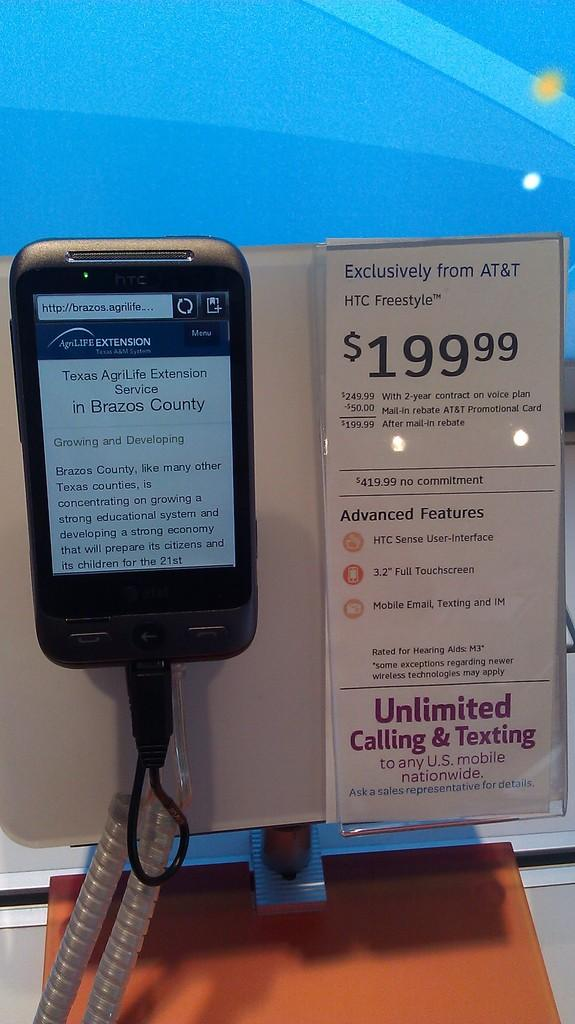Provide a one-sentence caption for the provided image. an HTC Freestyle cell phone with an Exclusive plan from AT&T. 